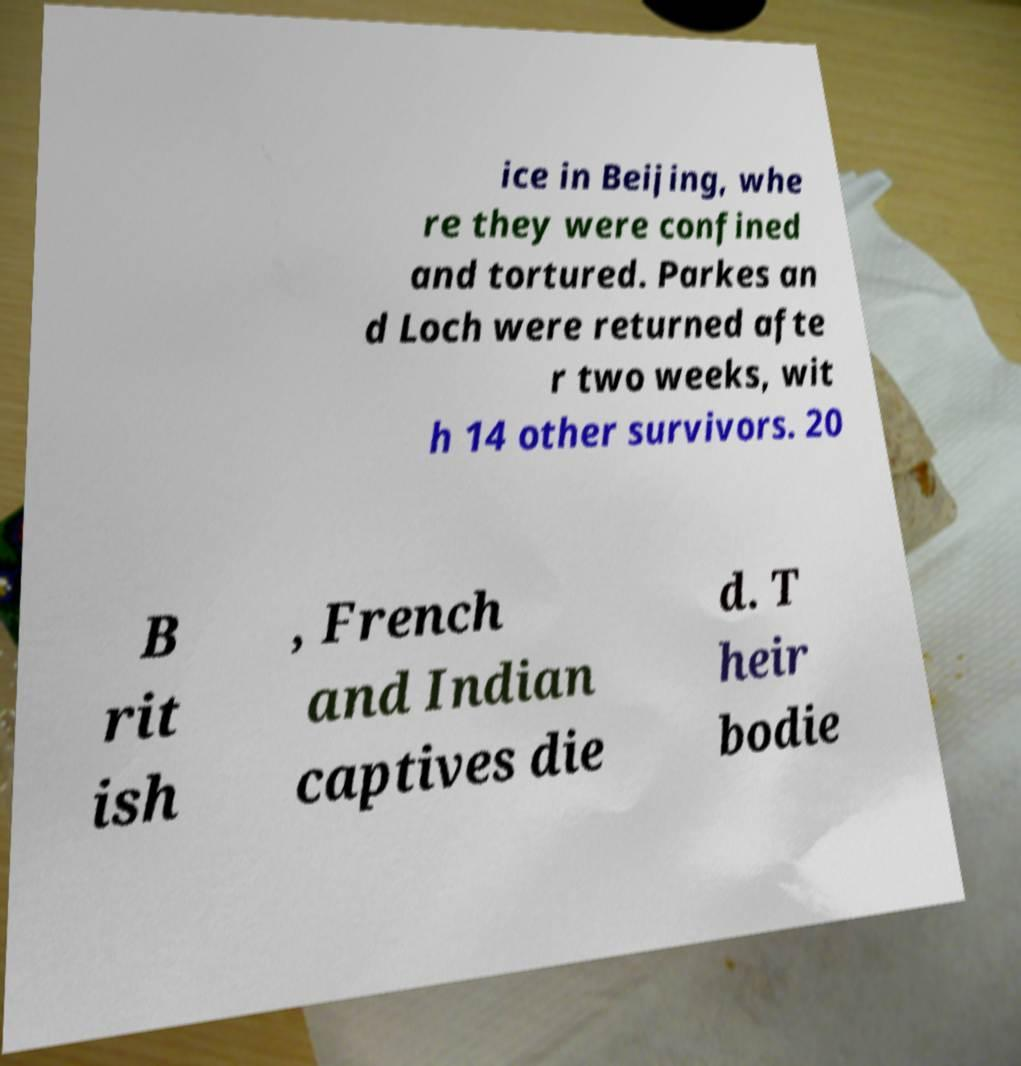Please identify and transcribe the text found in this image. ice in Beijing, whe re they were confined and tortured. Parkes an d Loch were returned afte r two weeks, wit h 14 other survivors. 20 B rit ish , French and Indian captives die d. T heir bodie 